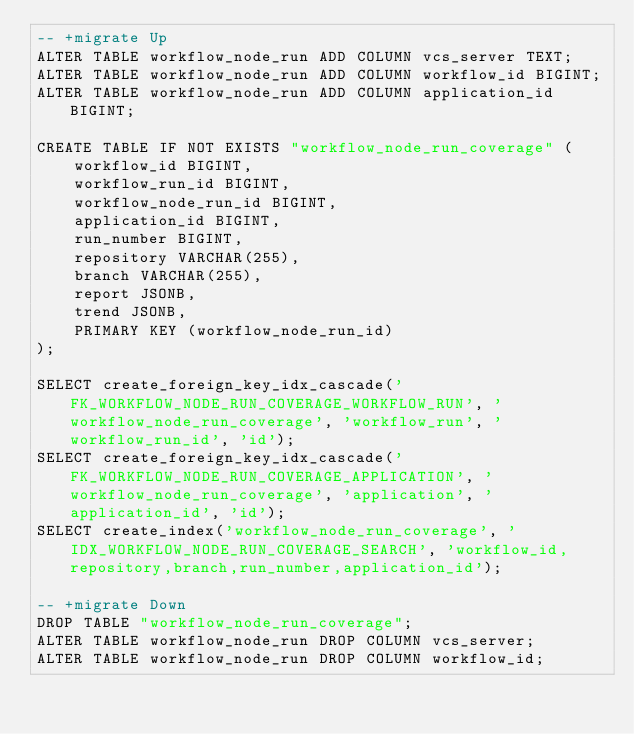<code> <loc_0><loc_0><loc_500><loc_500><_SQL_>-- +migrate Up
ALTER TABLE workflow_node_run ADD COLUMN vcs_server TEXT;
ALTER TABLE workflow_node_run ADD COLUMN workflow_id BIGINT;
ALTER TABLE workflow_node_run ADD COLUMN application_id BIGINT;

CREATE TABLE IF NOT EXISTS "workflow_node_run_coverage" (
    workflow_id BIGINT,
    workflow_run_id BIGINT,
    workflow_node_run_id BIGINT,
    application_id BIGINT,
    run_number BIGINT,
    repository VARCHAR(255),
    branch VARCHAR(255),
    report JSONB,
    trend JSONB,
    PRIMARY KEY (workflow_node_run_id)
);

SELECT create_foreign_key_idx_cascade('FK_WORKFLOW_NODE_RUN_COVERAGE_WORKFLOW_RUN', 'workflow_node_run_coverage', 'workflow_run', 'workflow_run_id', 'id');
SELECT create_foreign_key_idx_cascade('FK_WORKFLOW_NODE_RUN_COVERAGE_APPLICATION', 'workflow_node_run_coverage', 'application', 'application_id', 'id');
SELECT create_index('workflow_node_run_coverage', 'IDX_WORKFLOW_NODE_RUN_COVERAGE_SEARCH', 'workflow_id,repository,branch,run_number,application_id');

-- +migrate Down
DROP TABLE "workflow_node_run_coverage";
ALTER TABLE workflow_node_run DROP COLUMN vcs_server;
ALTER TABLE workflow_node_run DROP COLUMN workflow_id;
</code> 